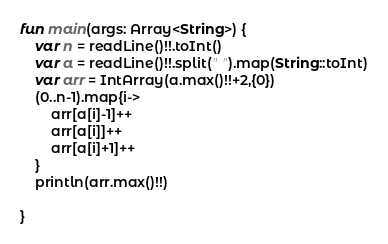<code> <loc_0><loc_0><loc_500><loc_500><_Kotlin_>fun main(args: Array<String>) {
    var n = readLine()!!.toInt()
    var a = readLine()!!.split(" ").map(String::toInt)
    var arr = IntArray(a.max()!!+2,{0})
    (0..n-1).map{i->
        arr[a[i]-1]++
        arr[a[i]]++
        arr[a[i]+1]++
    }
    println(arr.max()!!)
        
}</code> 